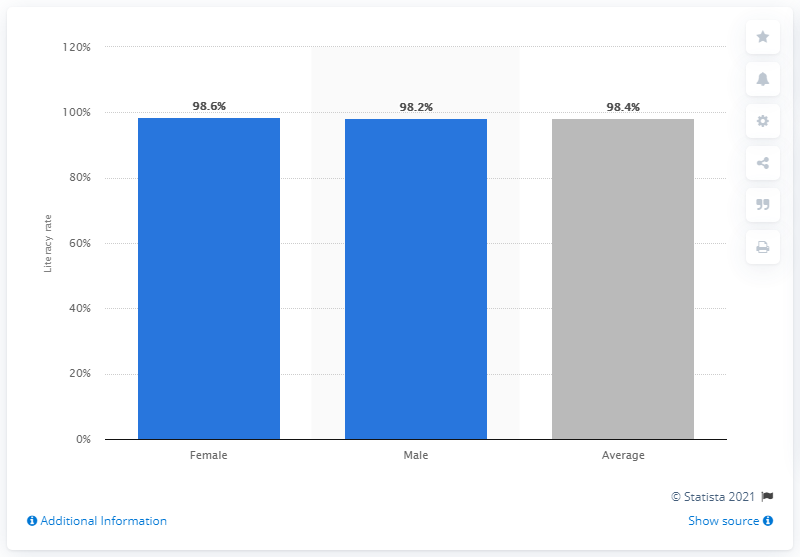Indicate a few pertinent items in this graphic. The youth literacy rate in Latin America and the Caribbean in 2016 was 98.4%. In 2016, the literacy rate among women between the ages of 15 and 24 in Latin America and the Caribbean was 98.4%. What is the difference between female and average? It is 0.2. According to the latest statistics, the literacy rate among males is 98.2%. 